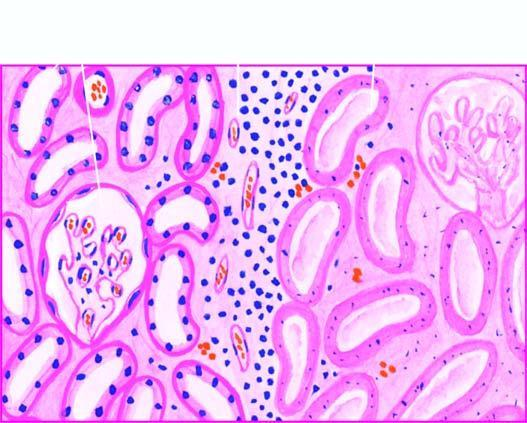what are still maintained?
Answer the question using a single word or phrase. The outlines of tubules 